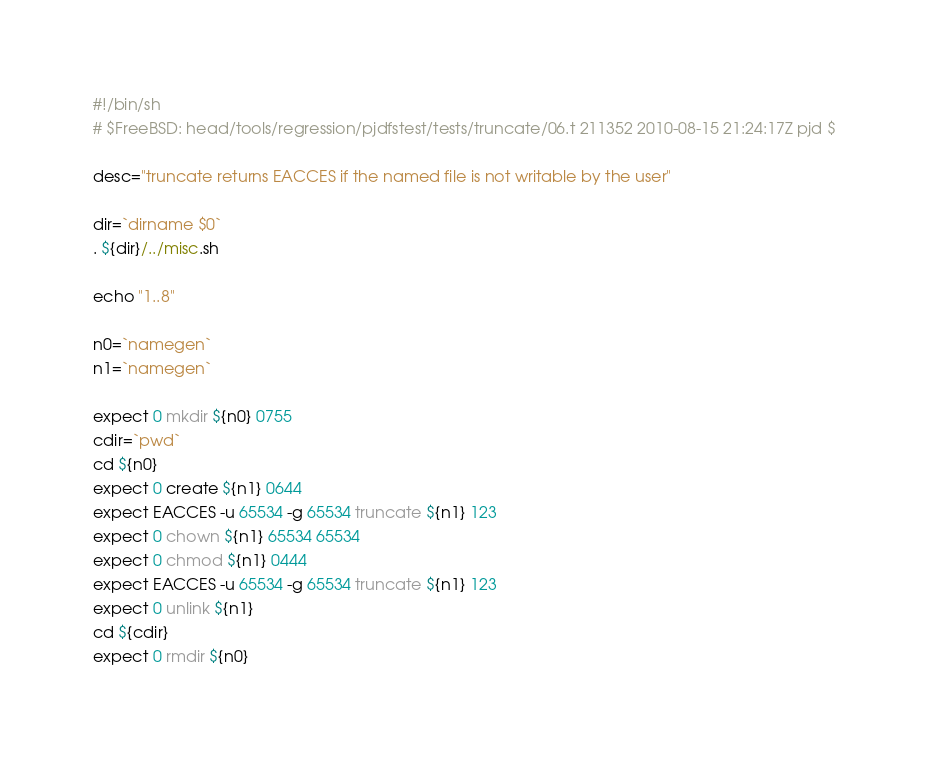Convert code to text. <code><loc_0><loc_0><loc_500><loc_500><_Perl_>#!/bin/sh
# $FreeBSD: head/tools/regression/pjdfstest/tests/truncate/06.t 211352 2010-08-15 21:24:17Z pjd $

desc="truncate returns EACCES if the named file is not writable by the user"

dir=`dirname $0`
. ${dir}/../misc.sh

echo "1..8"

n0=`namegen`
n1=`namegen`

expect 0 mkdir ${n0} 0755
cdir=`pwd`
cd ${n0}
expect 0 create ${n1} 0644
expect EACCES -u 65534 -g 65534 truncate ${n1} 123
expect 0 chown ${n1} 65534 65534
expect 0 chmod ${n1} 0444
expect EACCES -u 65534 -g 65534 truncate ${n1} 123
expect 0 unlink ${n1}
cd ${cdir}
expect 0 rmdir ${n0}
</code> 